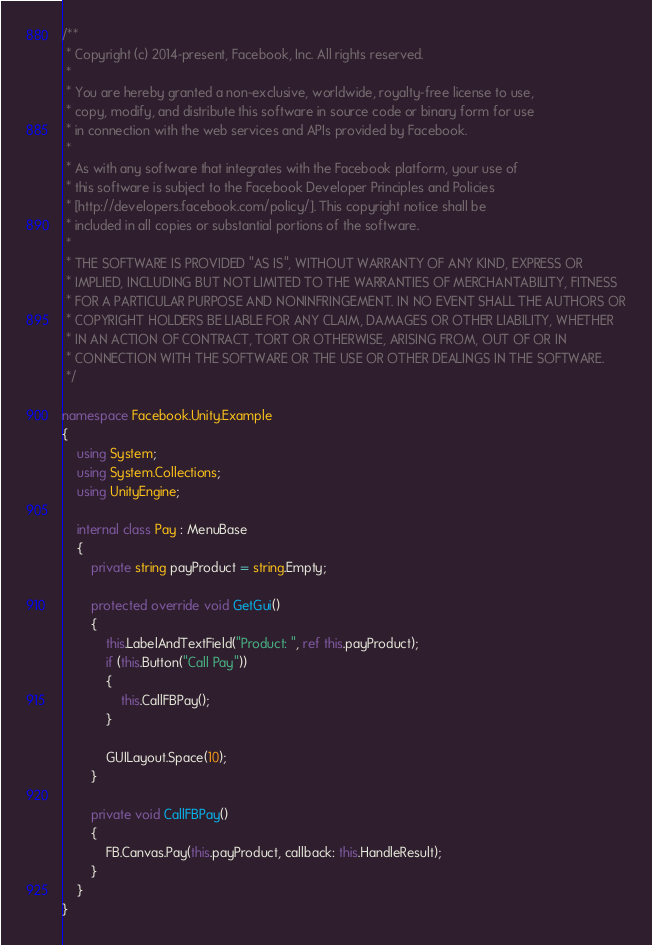<code> <loc_0><loc_0><loc_500><loc_500><_C#_>/**
 * Copyright (c) 2014-present, Facebook, Inc. All rights reserved.
 *
 * You are hereby granted a non-exclusive, worldwide, royalty-free license to use,
 * copy, modify, and distribute this software in source code or binary form for use
 * in connection with the web services and APIs provided by Facebook.
 *
 * As with any software that integrates with the Facebook platform, your use of
 * this software is subject to the Facebook Developer Principles and Policies
 * [http://developers.facebook.com/policy/]. This copyright notice shall be
 * included in all copies or substantial portions of the software.
 *
 * THE SOFTWARE IS PROVIDED "AS IS", WITHOUT WARRANTY OF ANY KIND, EXPRESS OR
 * IMPLIED, INCLUDING BUT NOT LIMITED TO THE WARRANTIES OF MERCHANTABILITY, FITNESS
 * FOR A PARTICULAR PURPOSE AND NONINFRINGEMENT. IN NO EVENT SHALL THE AUTHORS OR
 * COPYRIGHT HOLDERS BE LIABLE FOR ANY CLAIM, DAMAGES OR OTHER LIABILITY, WHETHER
 * IN AN ACTION OF CONTRACT, TORT OR OTHERWISE, ARISING FROM, OUT OF OR IN
 * CONNECTION WITH THE SOFTWARE OR THE USE OR OTHER DEALINGS IN THE SOFTWARE.
 */

namespace Facebook.Unity.Example
{
    using System;
    using System.Collections;
    using UnityEngine;

    internal class Pay : MenuBase
    {
        private string payProduct = string.Empty;

        protected override void GetGui()
        {
            this.LabelAndTextField("Product: ", ref this.payProduct);
            if (this.Button("Call Pay"))
            {
                this.CallFBPay();
            }

            GUILayout.Space(10);
        }

        private void CallFBPay()
        {
            FB.Canvas.Pay(this.payProduct, callback: this.HandleResult);
        }
    }
}
</code> 